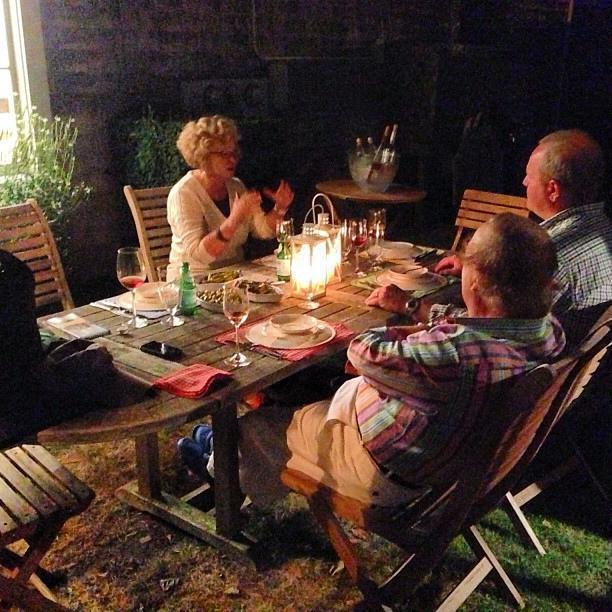How many red wines glasses are on the table?
Give a very brief answer. 4. How many men at the table?
Give a very brief answer. 2. How many people are there?
Give a very brief answer. 4. How many chairs are in the picture?
Give a very brief answer. 4. How many potted plants are there?
Give a very brief answer. 2. How many brown cows are there on the beach?
Give a very brief answer. 0. 